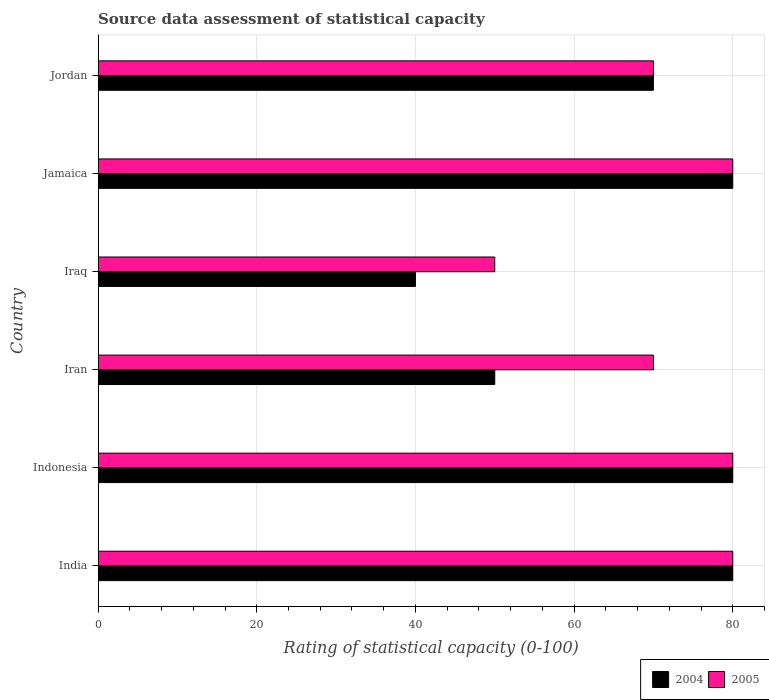How many groups of bars are there?
Offer a very short reply. 6. Are the number of bars per tick equal to the number of legend labels?
Your answer should be compact. Yes. Are the number of bars on each tick of the Y-axis equal?
Give a very brief answer. Yes. How many bars are there on the 2nd tick from the top?
Give a very brief answer. 2. How many bars are there on the 1st tick from the bottom?
Your answer should be compact. 2. What is the label of the 4th group of bars from the top?
Make the answer very short. Iran. In how many cases, is the number of bars for a given country not equal to the number of legend labels?
Offer a very short reply. 0. What is the rating of statistical capacity in 2005 in Iran?
Your answer should be very brief. 70. In which country was the rating of statistical capacity in 2005 minimum?
Your answer should be very brief. Iraq. What is the difference between the rating of statistical capacity in 2004 in Iraq and the rating of statistical capacity in 2005 in Jamaica?
Provide a short and direct response. -40. What is the average rating of statistical capacity in 2005 per country?
Your answer should be compact. 71.67. What is the difference between the rating of statistical capacity in 2004 and rating of statistical capacity in 2005 in India?
Give a very brief answer. 0. In how many countries, is the rating of statistical capacity in 2005 greater than 64 ?
Your answer should be compact. 5. Is the rating of statistical capacity in 2005 in India less than that in Jordan?
Your answer should be very brief. No. Is the difference between the rating of statistical capacity in 2004 in Iraq and Jamaica greater than the difference between the rating of statistical capacity in 2005 in Iraq and Jamaica?
Keep it short and to the point. No. In how many countries, is the rating of statistical capacity in 2004 greater than the average rating of statistical capacity in 2004 taken over all countries?
Offer a very short reply. 4. Is the sum of the rating of statistical capacity in 2004 in India and Jordan greater than the maximum rating of statistical capacity in 2005 across all countries?
Provide a succinct answer. Yes. What does the 1st bar from the top in Iran represents?
Offer a very short reply. 2005. What does the 1st bar from the bottom in Jordan represents?
Offer a terse response. 2004. Does the graph contain any zero values?
Ensure brevity in your answer.  No. Where does the legend appear in the graph?
Your response must be concise. Bottom right. How many legend labels are there?
Ensure brevity in your answer.  2. What is the title of the graph?
Offer a terse response. Source data assessment of statistical capacity. Does "1999" appear as one of the legend labels in the graph?
Your response must be concise. No. What is the label or title of the X-axis?
Offer a terse response. Rating of statistical capacity (0-100). What is the label or title of the Y-axis?
Provide a succinct answer. Country. What is the Rating of statistical capacity (0-100) in 2004 in Indonesia?
Keep it short and to the point. 80. What is the Rating of statistical capacity (0-100) in 2004 in Iran?
Provide a succinct answer. 50. What is the Rating of statistical capacity (0-100) in 2004 in Iraq?
Give a very brief answer. 40. What is the Rating of statistical capacity (0-100) of 2005 in Iraq?
Give a very brief answer. 50. What is the Rating of statistical capacity (0-100) in 2005 in Jordan?
Keep it short and to the point. 70. Across all countries, what is the minimum Rating of statistical capacity (0-100) in 2005?
Keep it short and to the point. 50. What is the total Rating of statistical capacity (0-100) of 2005 in the graph?
Give a very brief answer. 430. What is the difference between the Rating of statistical capacity (0-100) in 2005 in India and that in Indonesia?
Offer a terse response. 0. What is the difference between the Rating of statistical capacity (0-100) of 2004 in India and that in Iran?
Ensure brevity in your answer.  30. What is the difference between the Rating of statistical capacity (0-100) in 2005 in India and that in Iran?
Offer a very short reply. 10. What is the difference between the Rating of statistical capacity (0-100) of 2004 in India and that in Iraq?
Give a very brief answer. 40. What is the difference between the Rating of statistical capacity (0-100) in 2005 in India and that in Iraq?
Provide a short and direct response. 30. What is the difference between the Rating of statistical capacity (0-100) in 2005 in India and that in Jamaica?
Offer a very short reply. 0. What is the difference between the Rating of statistical capacity (0-100) in 2004 in Indonesia and that in Iraq?
Offer a terse response. 40. What is the difference between the Rating of statistical capacity (0-100) of 2005 in Indonesia and that in Iraq?
Provide a short and direct response. 30. What is the difference between the Rating of statistical capacity (0-100) of 2004 in Indonesia and that in Jamaica?
Give a very brief answer. 0. What is the difference between the Rating of statistical capacity (0-100) in 2005 in Indonesia and that in Jamaica?
Give a very brief answer. 0. What is the difference between the Rating of statistical capacity (0-100) in 2005 in Iran and that in Iraq?
Make the answer very short. 20. What is the difference between the Rating of statistical capacity (0-100) in 2005 in Iran and that in Jamaica?
Your response must be concise. -10. What is the difference between the Rating of statistical capacity (0-100) of 2004 in Iran and that in Jordan?
Give a very brief answer. -20. What is the difference between the Rating of statistical capacity (0-100) in 2005 in Iran and that in Jordan?
Offer a very short reply. 0. What is the difference between the Rating of statistical capacity (0-100) in 2004 in Iraq and that in Jamaica?
Your answer should be compact. -40. What is the difference between the Rating of statistical capacity (0-100) of 2004 in Iraq and that in Jordan?
Provide a succinct answer. -30. What is the difference between the Rating of statistical capacity (0-100) of 2005 in Iraq and that in Jordan?
Offer a very short reply. -20. What is the difference between the Rating of statistical capacity (0-100) in 2005 in Jamaica and that in Jordan?
Give a very brief answer. 10. What is the difference between the Rating of statistical capacity (0-100) in 2004 in India and the Rating of statistical capacity (0-100) in 2005 in Indonesia?
Your answer should be compact. 0. What is the difference between the Rating of statistical capacity (0-100) in 2004 in India and the Rating of statistical capacity (0-100) in 2005 in Iraq?
Give a very brief answer. 30. What is the difference between the Rating of statistical capacity (0-100) in 2004 in India and the Rating of statistical capacity (0-100) in 2005 in Jordan?
Keep it short and to the point. 10. What is the difference between the Rating of statistical capacity (0-100) in 2004 in Indonesia and the Rating of statistical capacity (0-100) in 2005 in Iran?
Provide a succinct answer. 10. What is the difference between the Rating of statistical capacity (0-100) of 2004 in Indonesia and the Rating of statistical capacity (0-100) of 2005 in Iraq?
Ensure brevity in your answer.  30. What is the difference between the Rating of statistical capacity (0-100) in 2004 in Indonesia and the Rating of statistical capacity (0-100) in 2005 in Jamaica?
Ensure brevity in your answer.  0. What is the difference between the Rating of statistical capacity (0-100) of 2004 in Iran and the Rating of statistical capacity (0-100) of 2005 in Jordan?
Provide a short and direct response. -20. What is the difference between the Rating of statistical capacity (0-100) of 2004 in Iraq and the Rating of statistical capacity (0-100) of 2005 in Jordan?
Make the answer very short. -30. What is the difference between the Rating of statistical capacity (0-100) of 2004 in Jamaica and the Rating of statistical capacity (0-100) of 2005 in Jordan?
Offer a terse response. 10. What is the average Rating of statistical capacity (0-100) of 2004 per country?
Your answer should be compact. 66.67. What is the average Rating of statistical capacity (0-100) of 2005 per country?
Provide a succinct answer. 71.67. What is the difference between the Rating of statistical capacity (0-100) in 2004 and Rating of statistical capacity (0-100) in 2005 in India?
Give a very brief answer. 0. What is the difference between the Rating of statistical capacity (0-100) in 2004 and Rating of statistical capacity (0-100) in 2005 in Indonesia?
Make the answer very short. 0. What is the difference between the Rating of statistical capacity (0-100) in 2004 and Rating of statistical capacity (0-100) in 2005 in Iran?
Your answer should be compact. -20. What is the difference between the Rating of statistical capacity (0-100) of 2004 and Rating of statistical capacity (0-100) of 2005 in Jordan?
Your response must be concise. 0. What is the ratio of the Rating of statistical capacity (0-100) of 2005 in India to that in Indonesia?
Give a very brief answer. 1. What is the ratio of the Rating of statistical capacity (0-100) of 2004 in India to that in Iran?
Provide a succinct answer. 1.6. What is the ratio of the Rating of statistical capacity (0-100) in 2005 in India to that in Iran?
Keep it short and to the point. 1.14. What is the ratio of the Rating of statistical capacity (0-100) in 2004 in India to that in Iraq?
Provide a succinct answer. 2. What is the ratio of the Rating of statistical capacity (0-100) of 2004 in India to that in Jordan?
Keep it short and to the point. 1.14. What is the ratio of the Rating of statistical capacity (0-100) in 2004 in Indonesia to that in Iran?
Your answer should be very brief. 1.6. What is the ratio of the Rating of statistical capacity (0-100) of 2005 in Indonesia to that in Iran?
Ensure brevity in your answer.  1.14. What is the ratio of the Rating of statistical capacity (0-100) in 2004 in Indonesia to that in Jamaica?
Keep it short and to the point. 1. What is the ratio of the Rating of statistical capacity (0-100) of 2004 in Indonesia to that in Jordan?
Make the answer very short. 1.14. What is the ratio of the Rating of statistical capacity (0-100) of 2005 in Indonesia to that in Jordan?
Your response must be concise. 1.14. What is the ratio of the Rating of statistical capacity (0-100) of 2004 in Iran to that in Jordan?
Provide a succinct answer. 0.71. What is the ratio of the Rating of statistical capacity (0-100) in 2005 in Iraq to that in Jamaica?
Make the answer very short. 0.62. What is the ratio of the Rating of statistical capacity (0-100) in 2004 in Iraq to that in Jordan?
Provide a succinct answer. 0.57. What is the ratio of the Rating of statistical capacity (0-100) of 2005 in Jamaica to that in Jordan?
Make the answer very short. 1.14. What is the difference between the highest and the second highest Rating of statistical capacity (0-100) in 2004?
Offer a terse response. 0. What is the difference between the highest and the lowest Rating of statistical capacity (0-100) in 2004?
Ensure brevity in your answer.  40. 